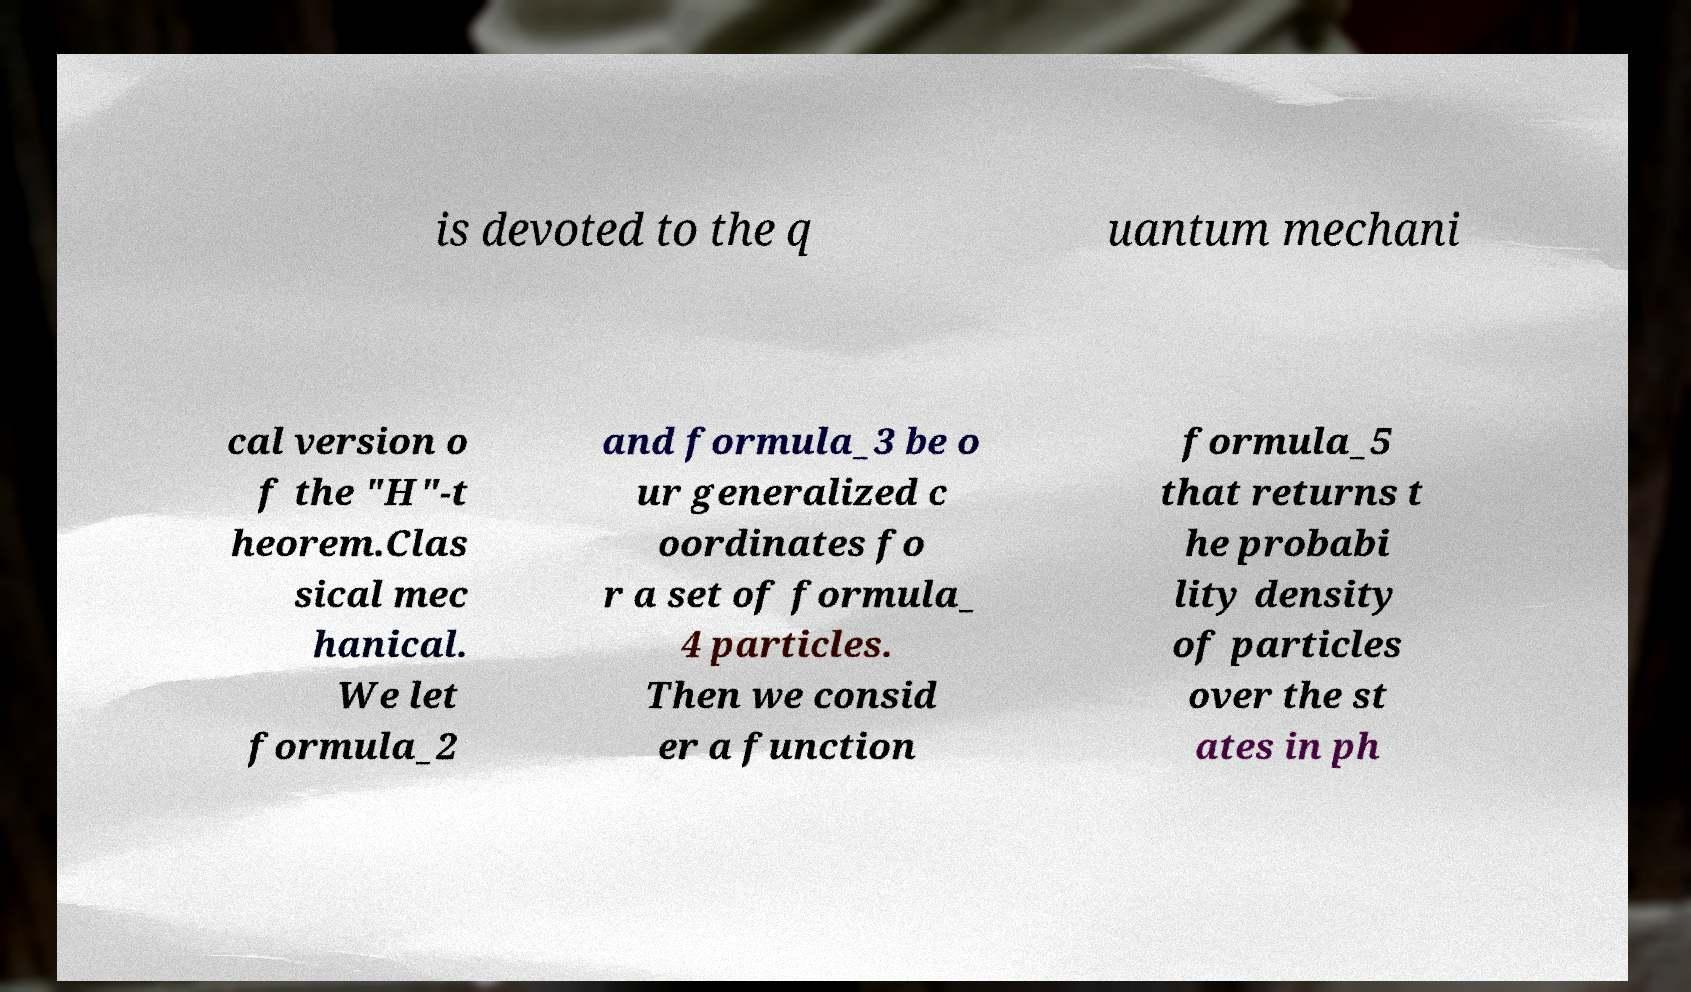For documentation purposes, I need the text within this image transcribed. Could you provide that? is devoted to the q uantum mechani cal version o f the "H"-t heorem.Clas sical mec hanical. We let formula_2 and formula_3 be o ur generalized c oordinates fo r a set of formula_ 4 particles. Then we consid er a function formula_5 that returns t he probabi lity density of particles over the st ates in ph 